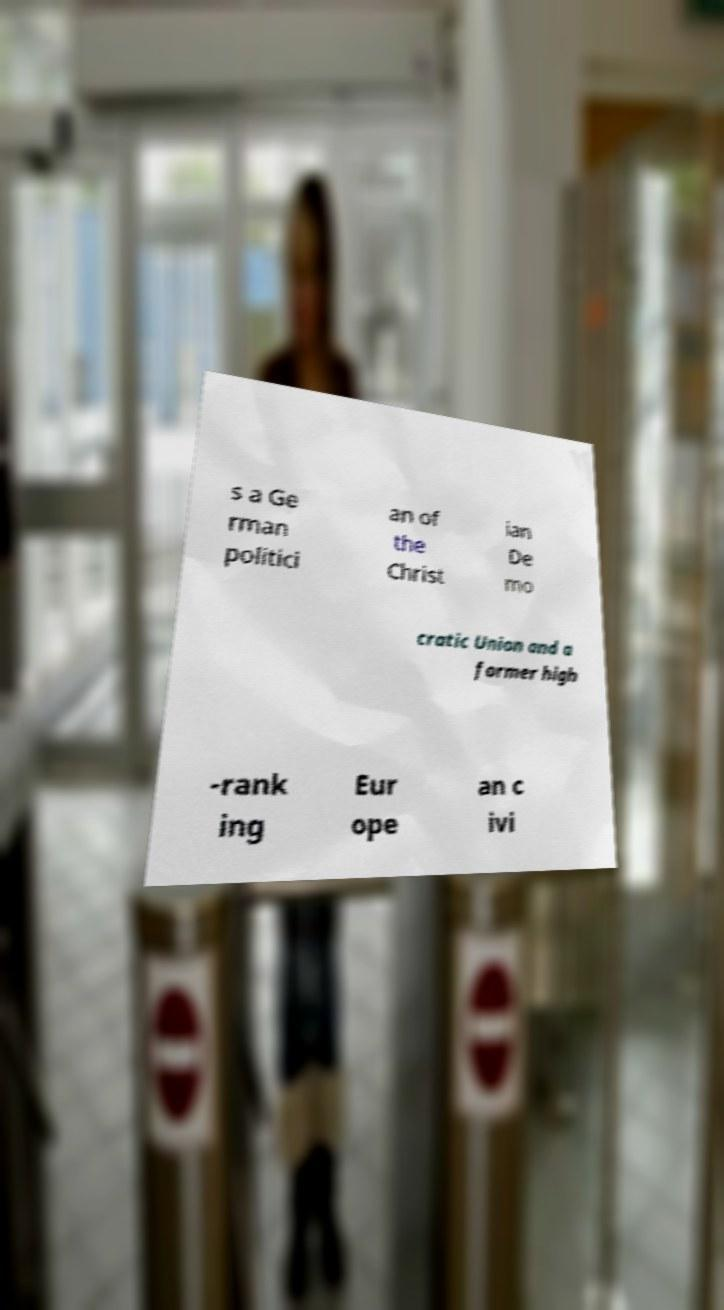Could you assist in decoding the text presented in this image and type it out clearly? s a Ge rman politici an of the Christ ian De mo cratic Union and a former high -rank ing Eur ope an c ivi 